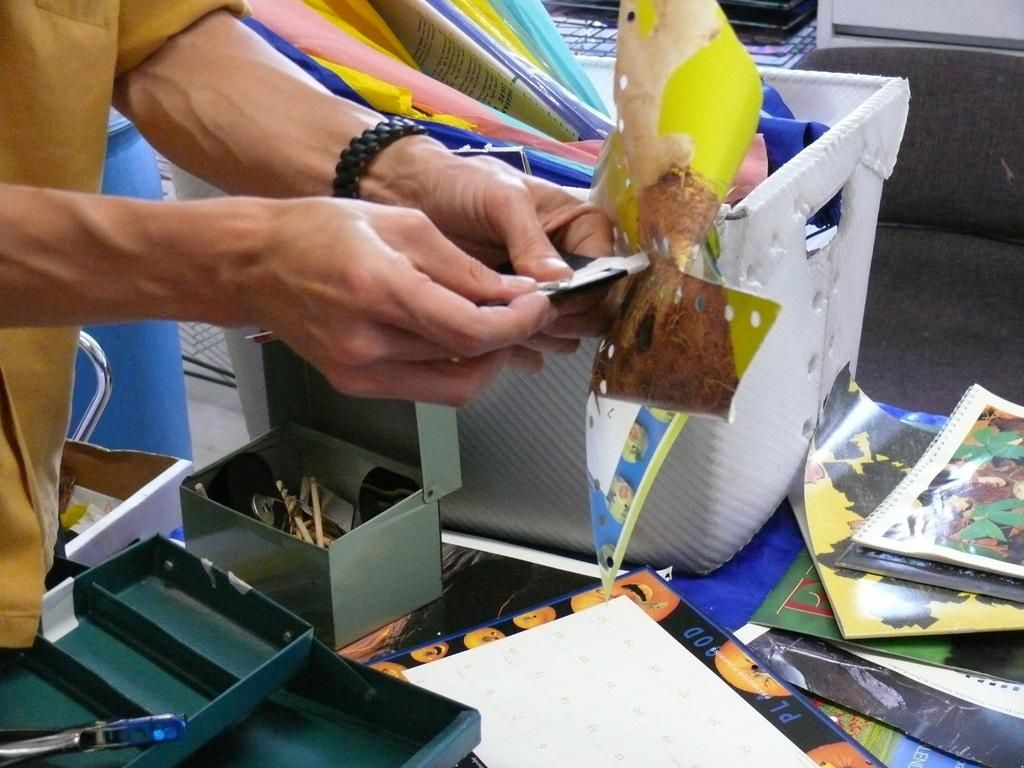What is the person in the image holding? There is a person holding an object in the image. What can be seen in the background of the image? There is a group of objects in a container in the background of the image. What is located at the bottom of the image? There is a group of objects at the bottom of the image. How much does the frog weigh in the image? There is no frog present in the image, so its weight cannot be determined. 